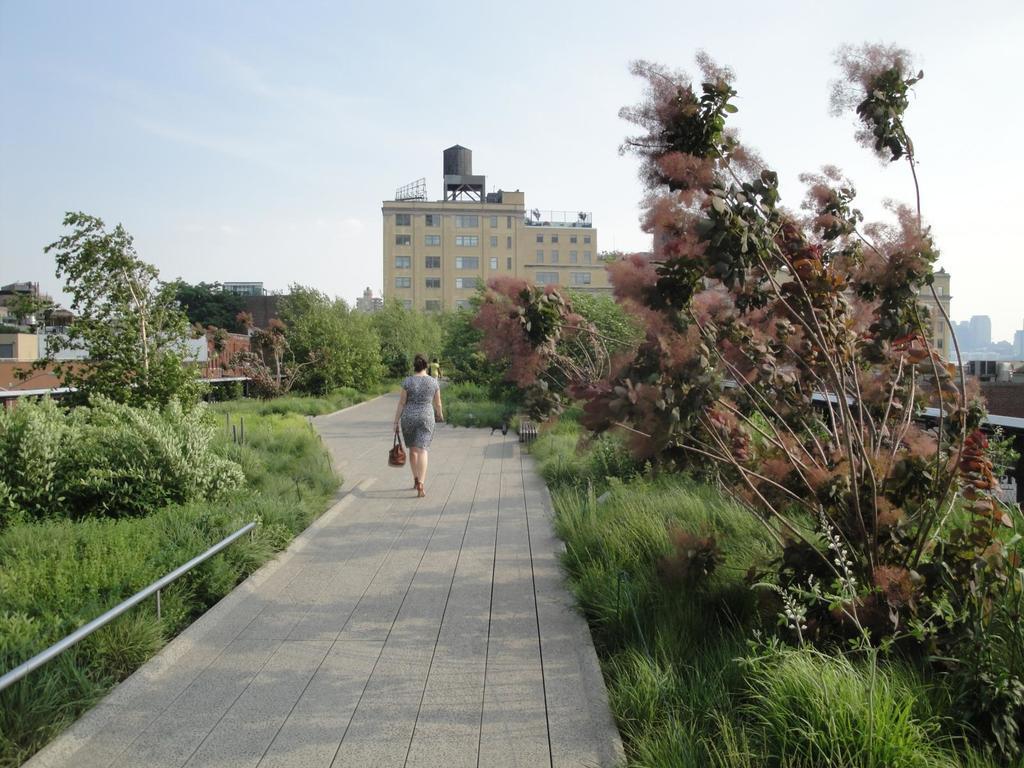Could you give a brief overview of what you see in this image? In this image we can see people walking on the pavement. To the both sides of the image there are trees, grass. In the background of the image there is a building, sky. 